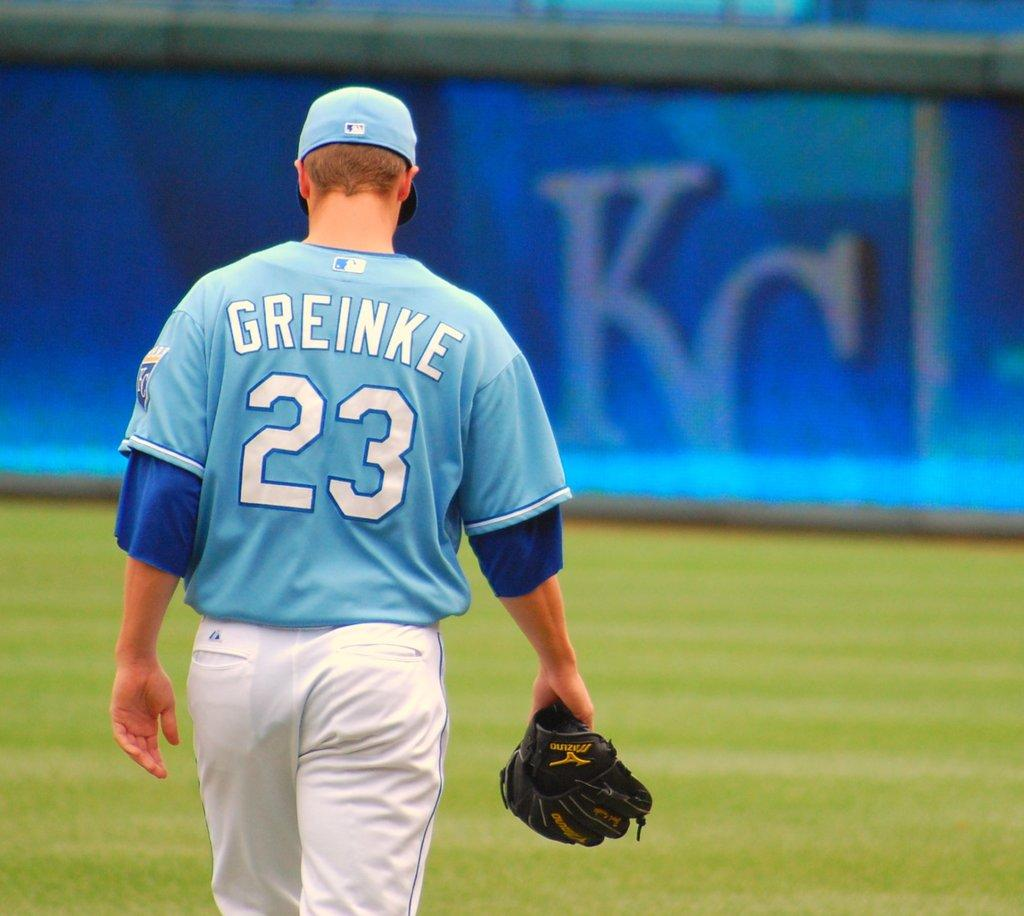<image>
Relay a brief, clear account of the picture shown. A basball player called Greinke and wearing the number 23 walks away from the camera carrying his mitt. 